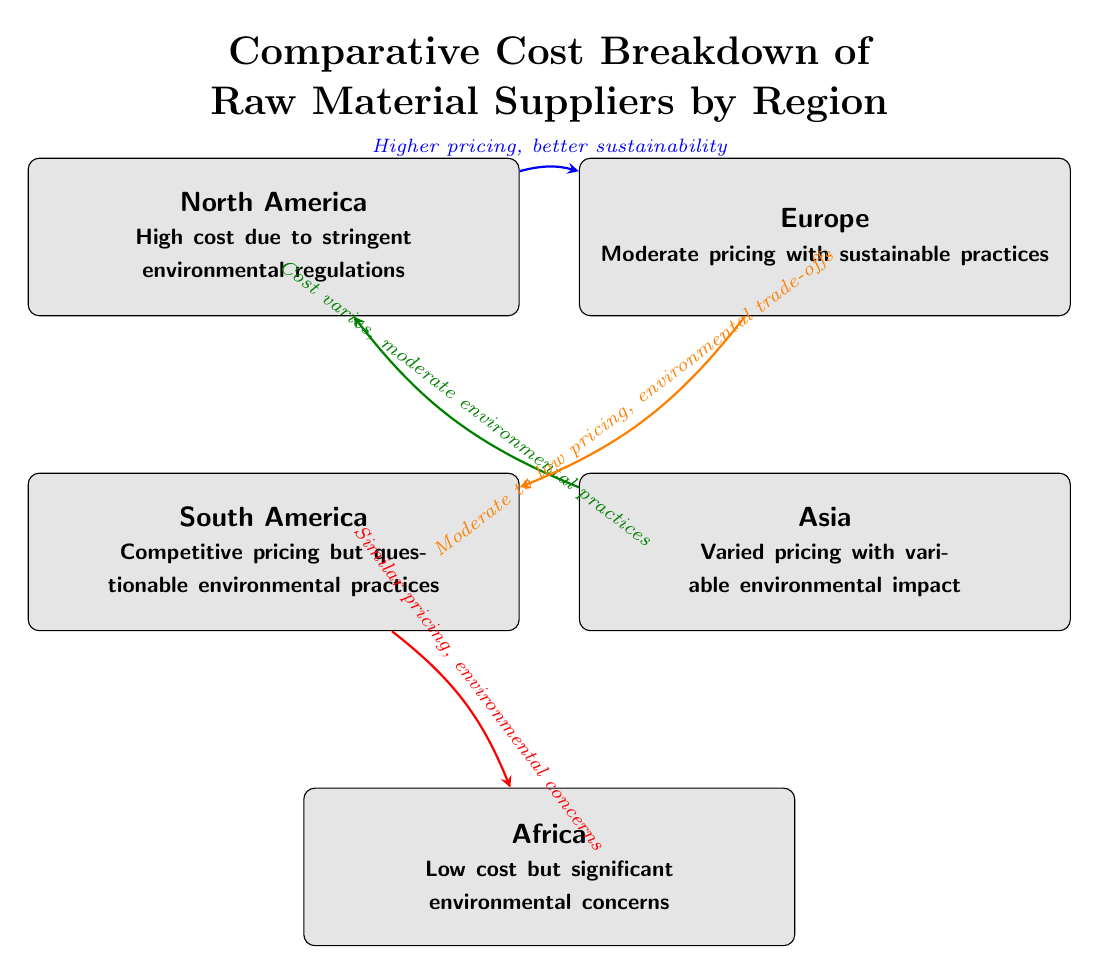What is the cost level in North America? The diagram states that the cost in North America is "High" due to stringent environmental regulations.
Answer: High Which region has low cost but significant environmental concerns? The diagram clearly identifies Africa as having "Low cost but significant environmental concerns."
Answer: Africa What type of pricing does Europe have? According to the diagram, Europe has "Moderate pricing with sustainable practices."
Answer: Moderate What is the relationship between South America and Africa? The diagram illustrates that South America has "Similar pricing, environmental concerns" to Africa, indicating a direct link with shared characteristics.
Answer: Similar pricing, environmental concerns How many regions are represented in the diagram? By counting the nodes, the diagram shows a total of five regions: North America, South America, Europe, Asia, and Africa.
Answer: Five Which region is associated with better sustainability despite higher pricing? The diagram indicates that North America is associated with "Higher pricing, better sustainability" when compared to Europe.
Answer: North America Which region has varied pricing and variable environmental impact? The diagram explicitly states that Asia has "Varied pricing with variable environmental impact."
Answer: Asia What is the connection between Europe and South America in terms of pricing? The diagram connects Europe and South America through the arrow indicating "Moderate to low pricing, environmental trade-offs," showing that Europe offers a difference in trade-off compared to South America.
Answer: Moderate to low pricing, environmental trade-offs Which region is noted for competitive pricing but questioned for environmental practices? The diagram refers to South America as having "Competitive pricing but questionable environmental practices."
Answer: South America 